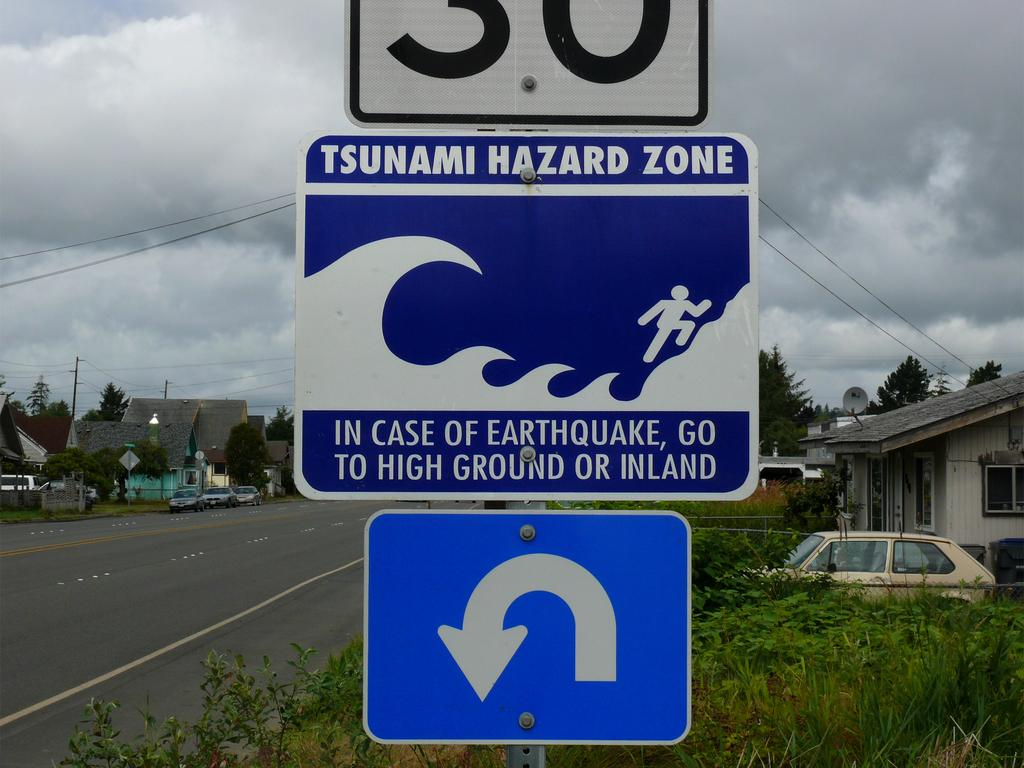<image>
Offer a succinct explanation of the picture presented. The sign along a street warns that it is in a tsunami hazard zone. 